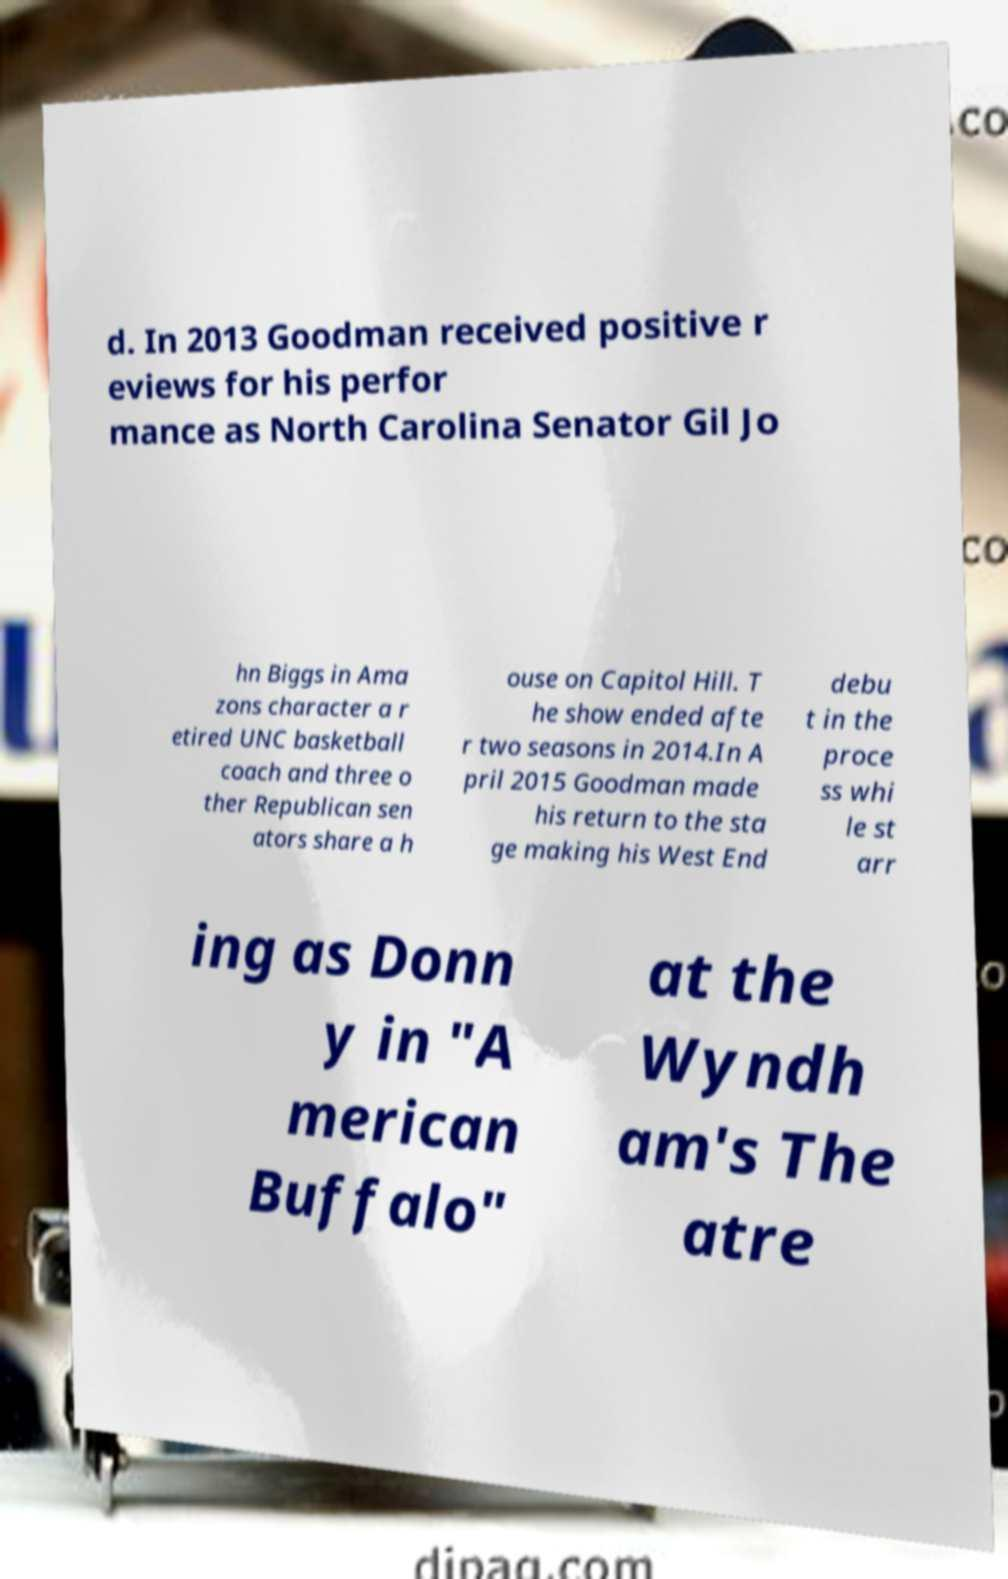Please identify and transcribe the text found in this image. d. In 2013 Goodman received positive r eviews for his perfor mance as North Carolina Senator Gil Jo hn Biggs in Ama zons character a r etired UNC basketball coach and three o ther Republican sen ators share a h ouse on Capitol Hill. T he show ended afte r two seasons in 2014.In A pril 2015 Goodman made his return to the sta ge making his West End debu t in the proce ss whi le st arr ing as Donn y in "A merican Buffalo" at the Wyndh am's The atre 